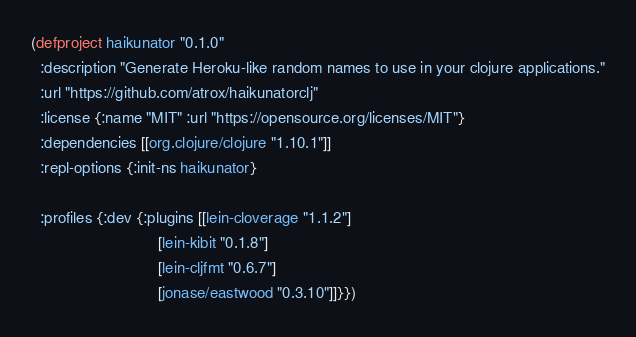<code> <loc_0><loc_0><loc_500><loc_500><_Clojure_>(defproject haikunator "0.1.0"
  :description "Generate Heroku-like random names to use in your clojure applications."
  :url "https://github.com/atrox/haikunatorclj"
  :license {:name "MIT" :url "https://opensource.org/licenses/MIT"}
  :dependencies [[org.clojure/clojure "1.10.1"]]
  :repl-options {:init-ns haikunator}

  :profiles {:dev {:plugins [[lein-cloverage "1.1.2"]
                             [lein-kibit "0.1.8"]
                             [lein-cljfmt "0.6.7"]
                             [jonase/eastwood "0.3.10"]]}})
</code> 